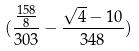Convert formula to latex. <formula><loc_0><loc_0><loc_500><loc_500>( \frac { \frac { 1 5 8 } { 8 } } { 3 0 3 } - \frac { \sqrt { 4 } - 1 0 } { 3 4 8 } )</formula> 